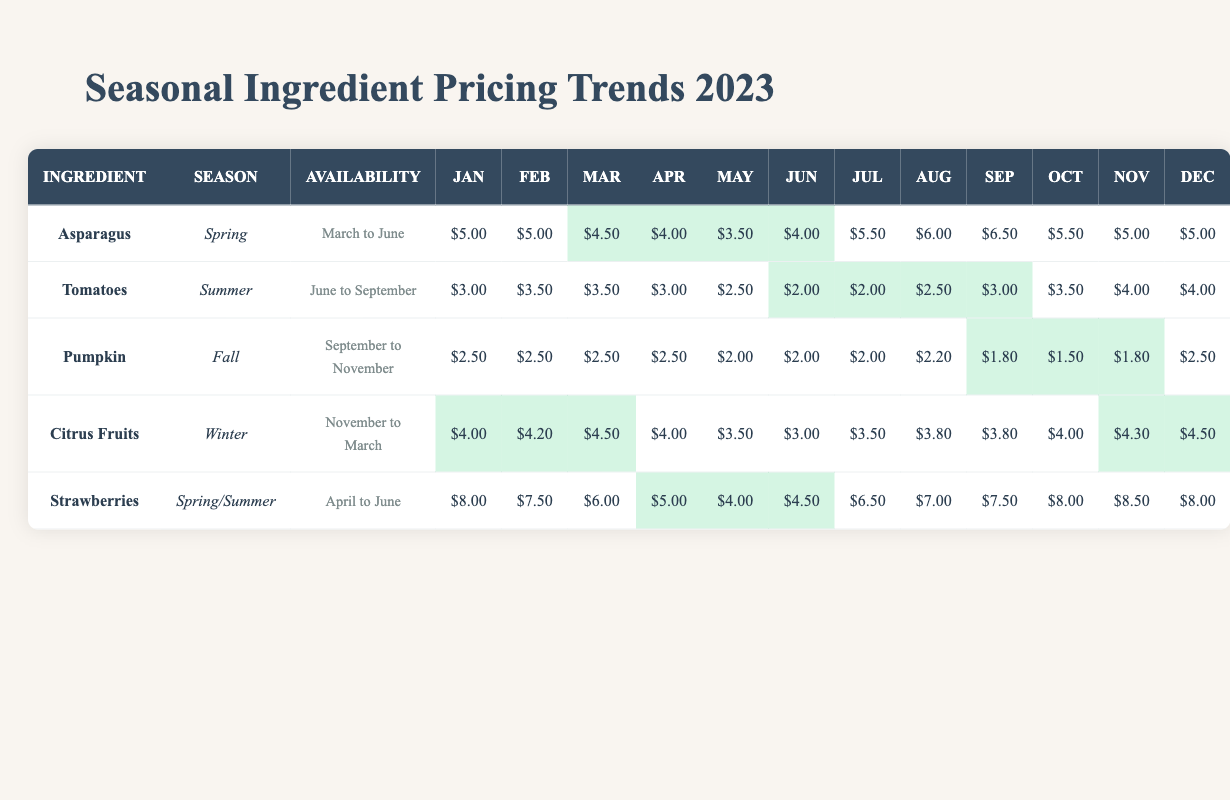What is the lowest average price per kilogram for Pumpkin in 2023? By checking the table, the average prices for Pumpkin are as follows: $2.50 (January to April), $2.00 (May to July), $2.20 (August), $1.80 (September), $1.50 (October), $1.80 (November), and $2.50 (December). The lowest value is $1.50 in October.
Answer: $1.50 During which months are Tomatoes least expensive on average? The average prices for Tomatoes from June to September are $2.00 in June and July, then $2.50 in August, and $3.00 in September. The lowest prices are in June and July where they are both $2.00.
Answer: June and July What is the percentage decrease in average price for Asparagus from April to May? The price for Asparagus in April is $4.00 and in May is $3.50. The decrease is $4.00 - $3.50 = $0.50. The percentage decrease is ($0.50 / $4.00) * 100 = 12.5%.
Answer: 12.5% Is Citrus Fruits available in May? Citrus Fruits are available from November to March; thus, it is not available in May.
Answer: No What is the average price per kilogram of Strawberries from April to June? The average prices from April to June are $5.00 (April), $4.00 (May), and $4.50 (June). The sum of these is $5.00 + $4.00 + $4.50 = $13.50. The average is $13.50 / 3 = $4.50.
Answer: $4.50 Which ingredient has the highest average price during its peak season? During its peak season from April to June, Strawberries have an average price of $5.00 (April), $4.00 (May), and $4.50 (June). The highest value is $5.00 in April.
Answer: Strawberries How does the average price of Tomatoes change from May to August? The price of Tomatoes in May is $2.50, in June is $2.00, in July is $2.00, and in August is $2.50. Starting from May ($2.50) to June ($2.00) is a decrease of $0.50, remaining at $2.00 in July, and then increasing back to $2.50 in August.
Answer: It decreases then increases What is the average price of Citrus Fruits from January to March? The average prices for Citrus Fruits are $4.00 (January), $4.20 (February), and $4.50 (March). The sum is $4.00 + $4.20 + $4.50 = $12.70. The average is $12.70 / 3 = approximately $4.23.
Answer: Approximately $4.23 Is there a seasonal overlap in the availability of Asparagus and Strawberries? Asparagus is available from March to June, and Strawberries are available from April to June, indicating a seasonal overlap from April to June.
Answer: Yes What is the trend of average prices for Pumpkins from July to November? The average prices are $2.00 (July), $2.00 (August), $2.20 (September), $1.80 (October), and $1.50 (November). The prices show a decreasing trend from July to November.
Answer: The trend is decreasing 